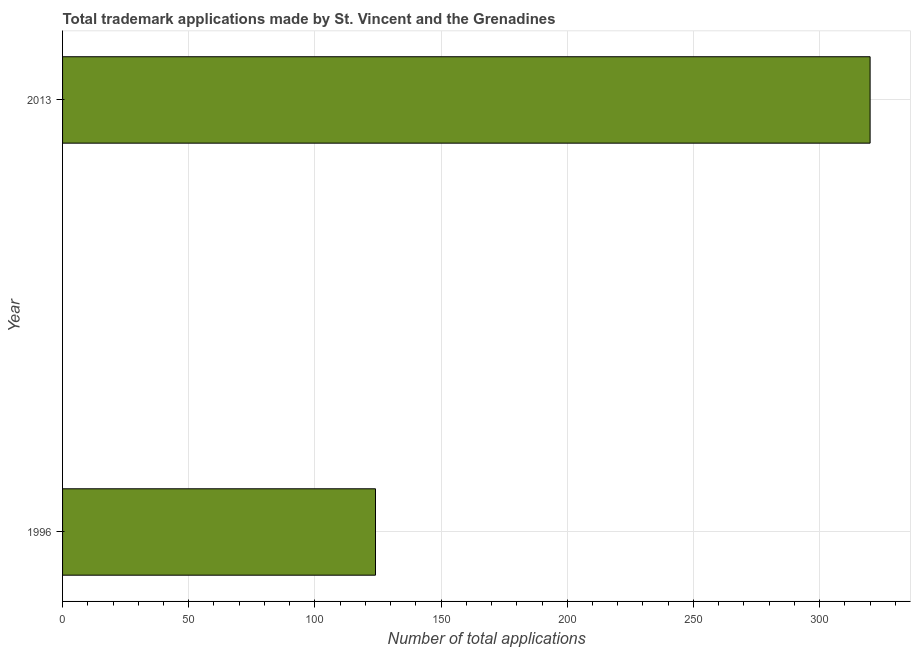Does the graph contain any zero values?
Your response must be concise. No. Does the graph contain grids?
Ensure brevity in your answer.  Yes. What is the title of the graph?
Offer a terse response. Total trademark applications made by St. Vincent and the Grenadines. What is the label or title of the X-axis?
Your response must be concise. Number of total applications. What is the number of trademark applications in 1996?
Your answer should be compact. 124. Across all years, what is the maximum number of trademark applications?
Your answer should be very brief. 320. Across all years, what is the minimum number of trademark applications?
Offer a very short reply. 124. In which year was the number of trademark applications maximum?
Offer a very short reply. 2013. In which year was the number of trademark applications minimum?
Make the answer very short. 1996. What is the sum of the number of trademark applications?
Make the answer very short. 444. What is the difference between the number of trademark applications in 1996 and 2013?
Your response must be concise. -196. What is the average number of trademark applications per year?
Provide a succinct answer. 222. What is the median number of trademark applications?
Your answer should be very brief. 222. Do a majority of the years between 2013 and 1996 (inclusive) have number of trademark applications greater than 220 ?
Ensure brevity in your answer.  No. What is the ratio of the number of trademark applications in 1996 to that in 2013?
Your answer should be very brief. 0.39. How many bars are there?
Ensure brevity in your answer.  2. How many years are there in the graph?
Keep it short and to the point. 2. What is the Number of total applications of 1996?
Your response must be concise. 124. What is the Number of total applications in 2013?
Your answer should be compact. 320. What is the difference between the Number of total applications in 1996 and 2013?
Make the answer very short. -196. What is the ratio of the Number of total applications in 1996 to that in 2013?
Keep it short and to the point. 0.39. 